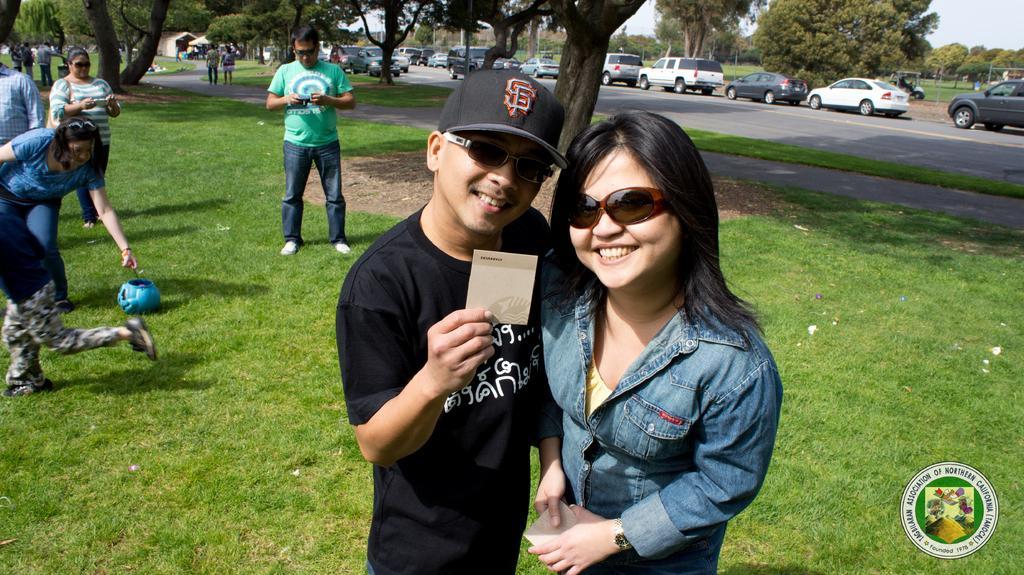How would you summarize this image in a sentence or two? In this image I can see grass ground and on it I can see number of people are standing. In the front I can see one man is holding a card and wearing a cap. I can also see two persons are wearing shades and I can also see smile on their faces. In the background I can see number of trees, a building and number of vehicles on the road. On the bottom right side of this image I can see a watermark and on the left side I can see a blue colour thing on the ground. 